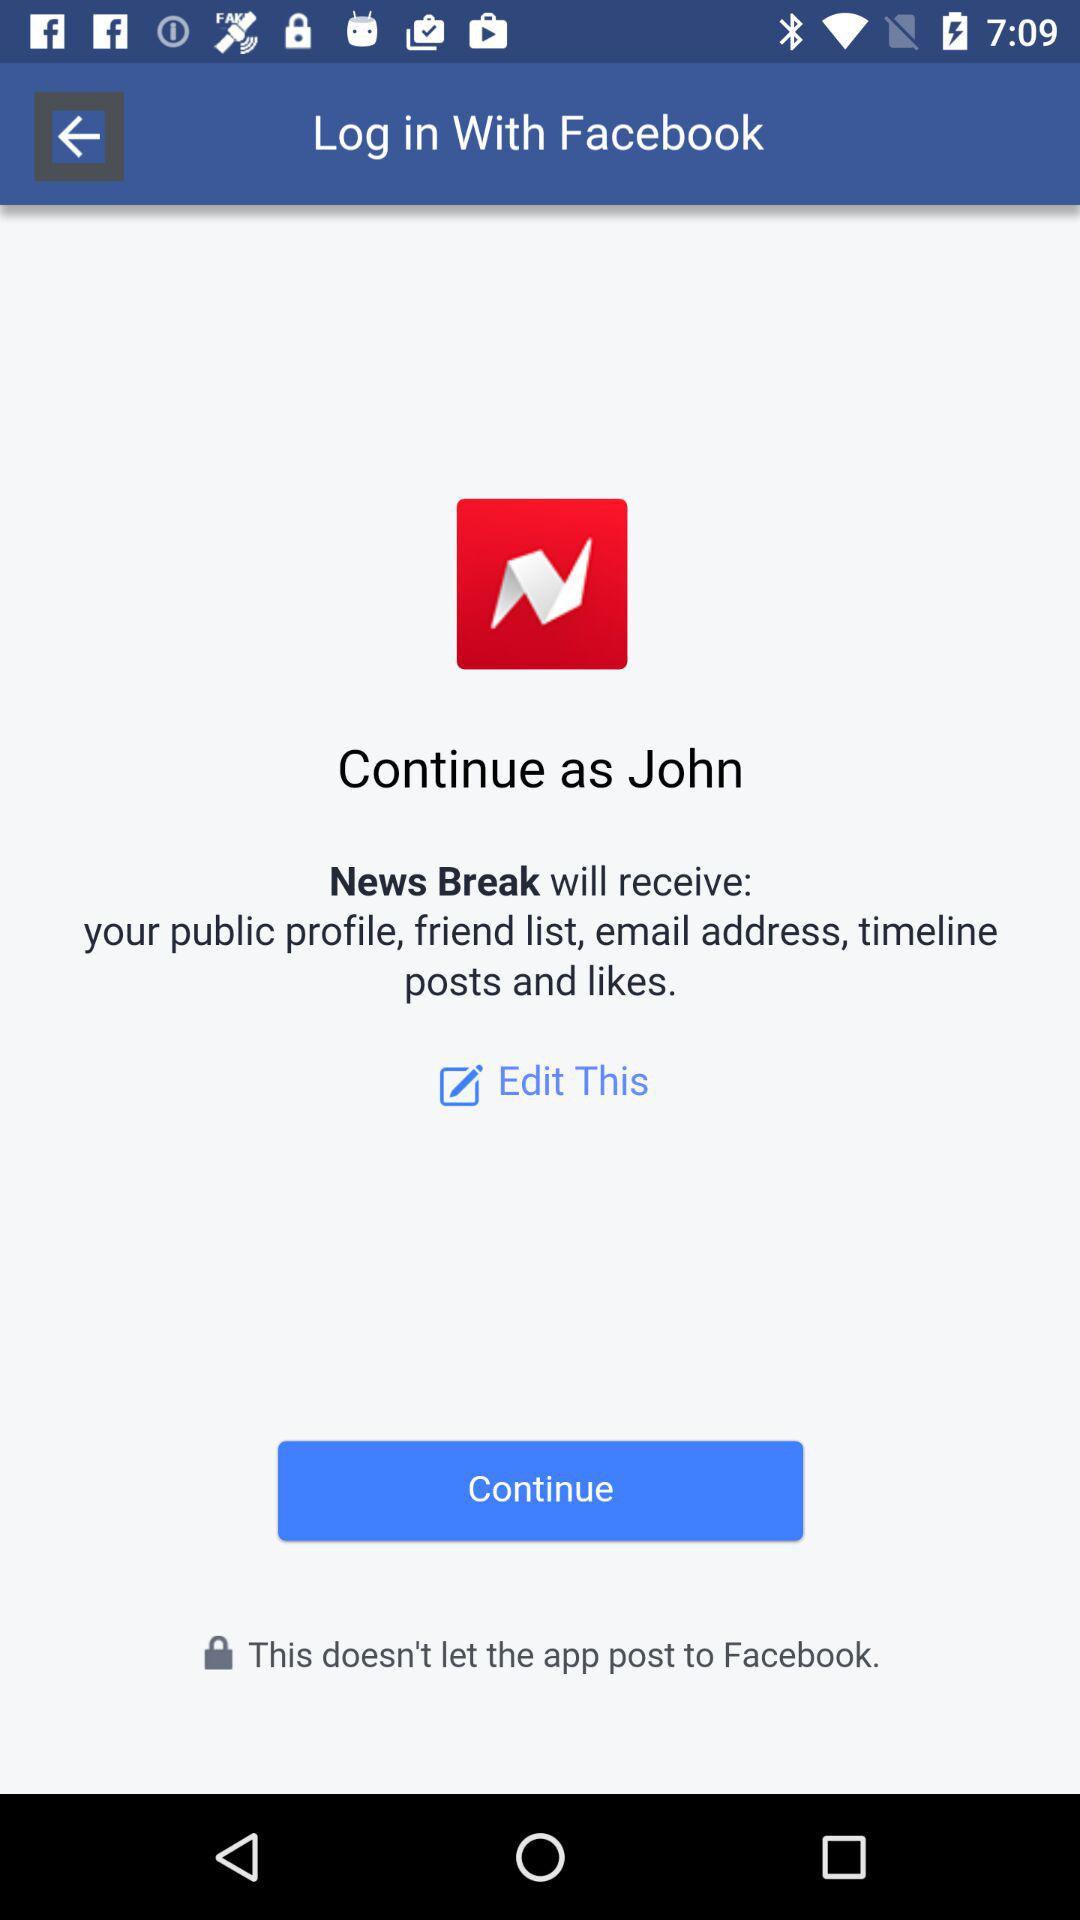Which application is used for logging in? The application used for logging in is "Facebook". 